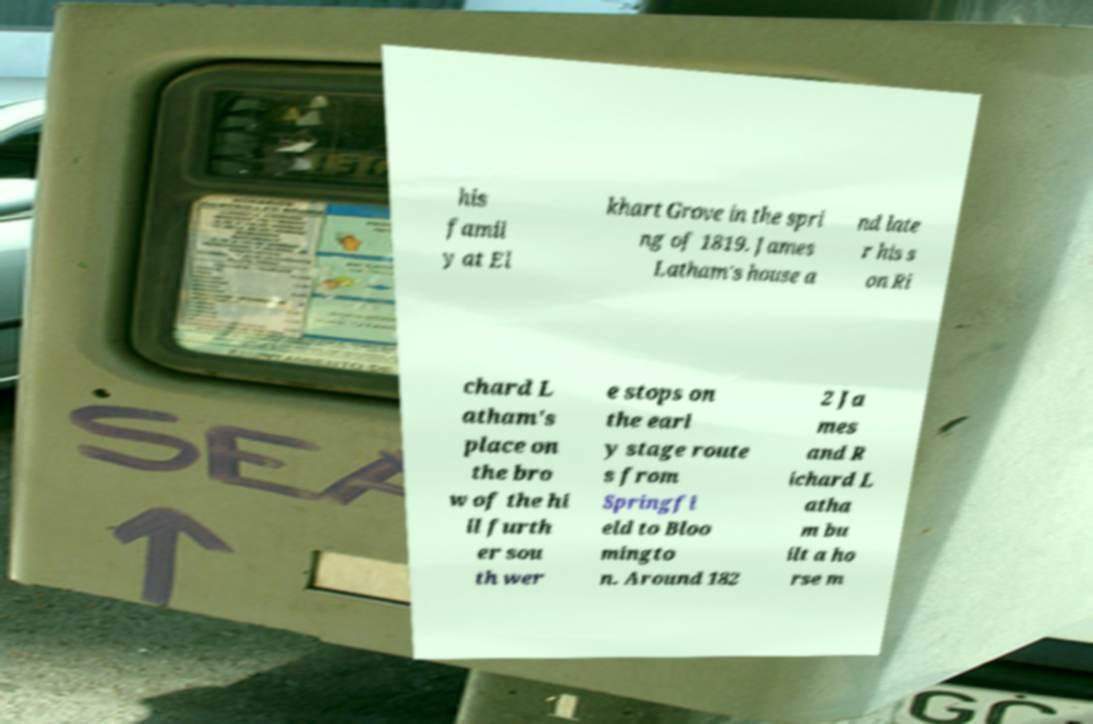Please read and relay the text visible in this image. What does it say? his famil y at El khart Grove in the spri ng of 1819. James Latham's house a nd late r his s on Ri chard L atham's place on the bro w of the hi ll furth er sou th wer e stops on the earl y stage route s from Springfi eld to Bloo mingto n. Around 182 2 Ja mes and R ichard L atha m bu ilt a ho rse m 